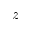<formula> <loc_0><loc_0><loc_500><loc_500>z</formula> 